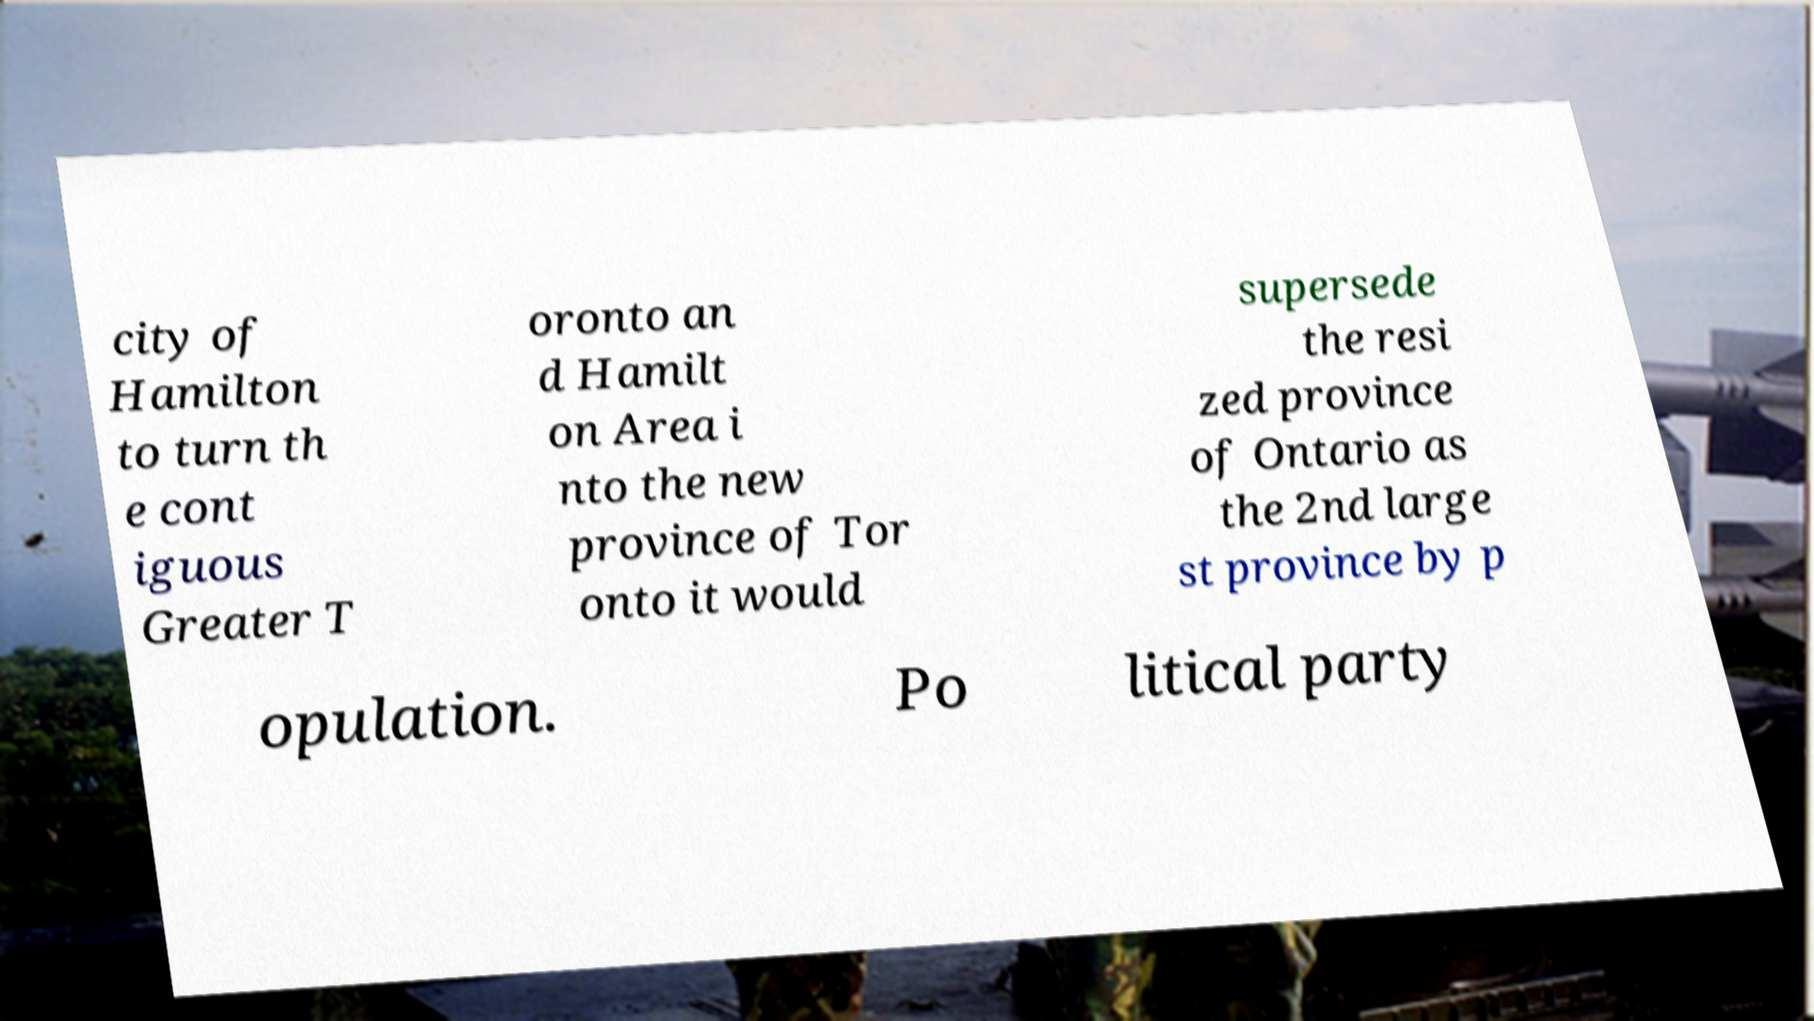What messages or text are displayed in this image? I need them in a readable, typed format. city of Hamilton to turn th e cont iguous Greater T oronto an d Hamilt on Area i nto the new province of Tor onto it would supersede the resi zed province of Ontario as the 2nd large st province by p opulation. Po litical party 